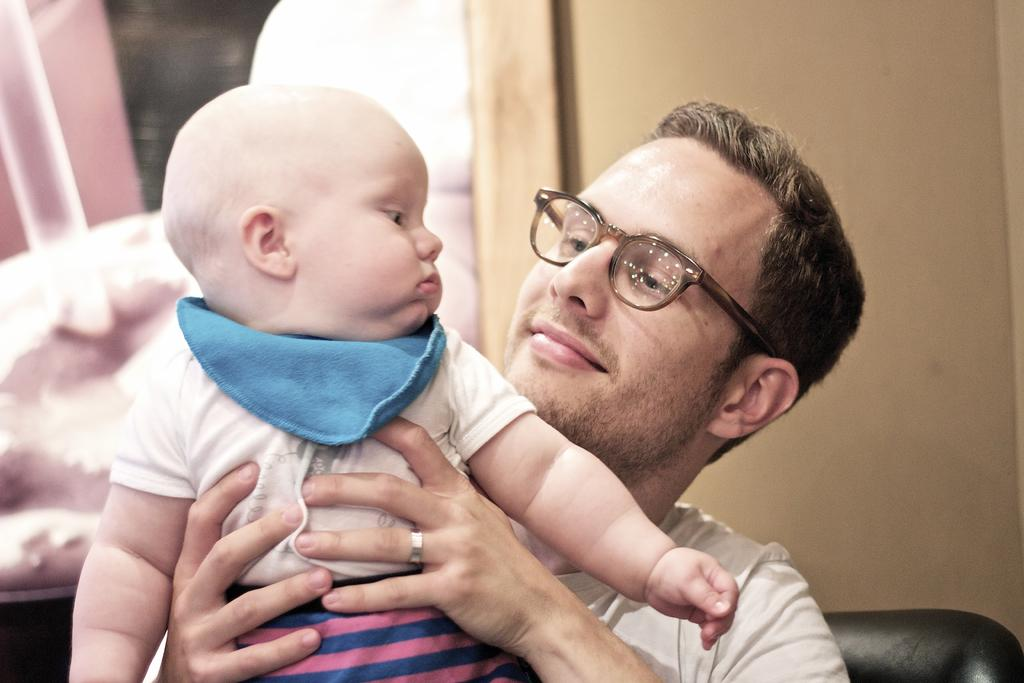What is the main subject of the image? The main subject of the image is a man. What is the man doing in the image? The man is holding a kid in his hand. What is the man's facial expression in the image? The man is smiling. What can be seen in the background of the image? There is a wall and an object that is pink in color in the background. What language is the man speaking to the kid in the image? The image does not provide any information about the language being spoken, as there is no audio or text present. --- Facts: 1. There is a car in the image. 2. The car is red. 3. The car has four wheels. 4. There are people in the car. 5. The car is parked on the street. Absurd Topics: parrot, sand, volcano Conversation: What is the main subject of the image? The main subject of the image is a car. What color is the car? The car is red. How many wheels does the car have? A: The car has four wheels. Are there any passengers in the car? Yes, there are people in the car. Where is the car located in the image? The car is parked on the street. Reasoning: Let's think step by step in order to produce the conversation. We start by identifying the main subject of the image, which is the car. Then, we describe the car's color, number of wheels, and the presence of passengers. Finally, we mention the car's location, which is parked on the street. Absurd Question/Answer: Can you see a volcano erupting in the background of the image? There is no volcano present in the image; it features a red car parked on the street. 